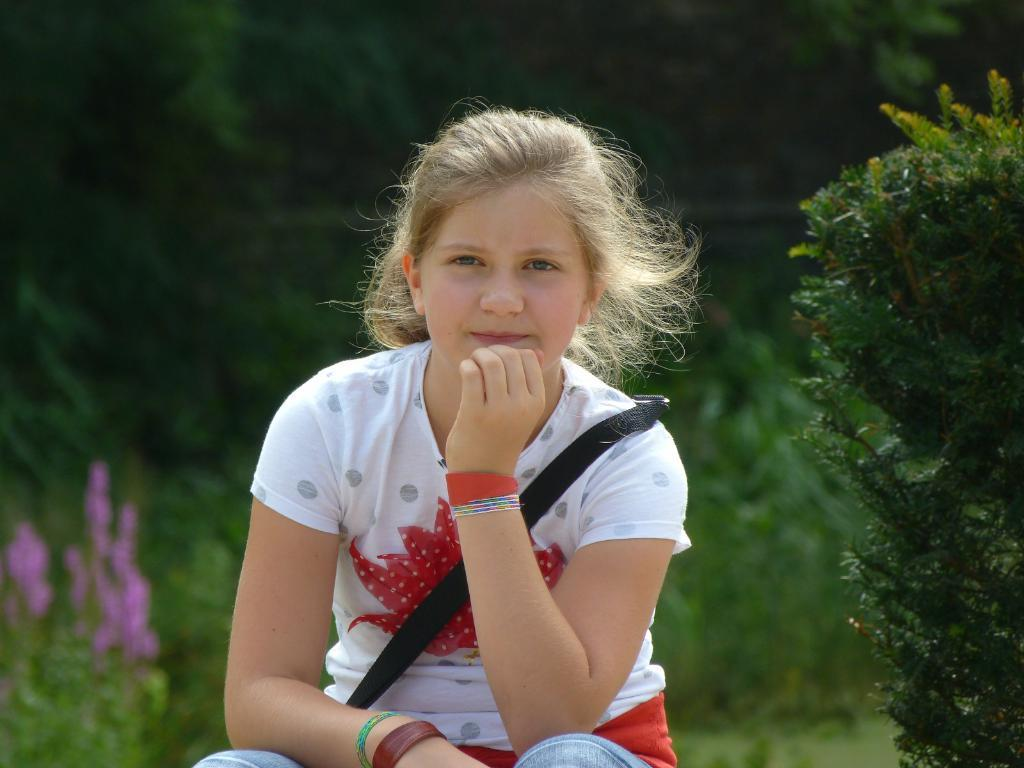Who is the main subject in the image? There is a girl in the image. What is the girl wearing? The girl is wearing a white dress. What is the girl doing in the image? The girl is sitting. What can be seen in the background of the image? There are plants and trees in the background of the image. What type of fruit is the girl holding in the image? There is no fruit visible in the image; the girl is not holding any fruit. What type of sponge is being used by the girl in the image? There is no sponge present in the image; the girl is simply sitting and wearing a white dress. 